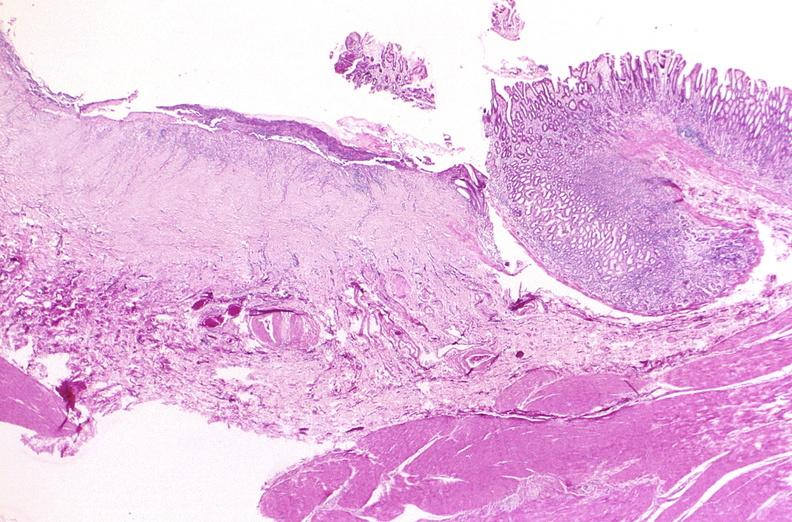what is present?
Answer the question using a single word or phrase. Gastrointestinal 